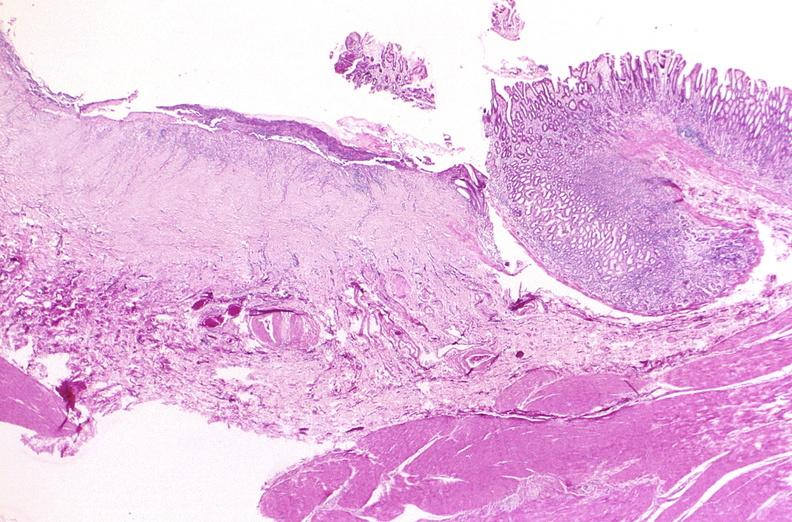what is present?
Answer the question using a single word or phrase. Gastrointestinal 